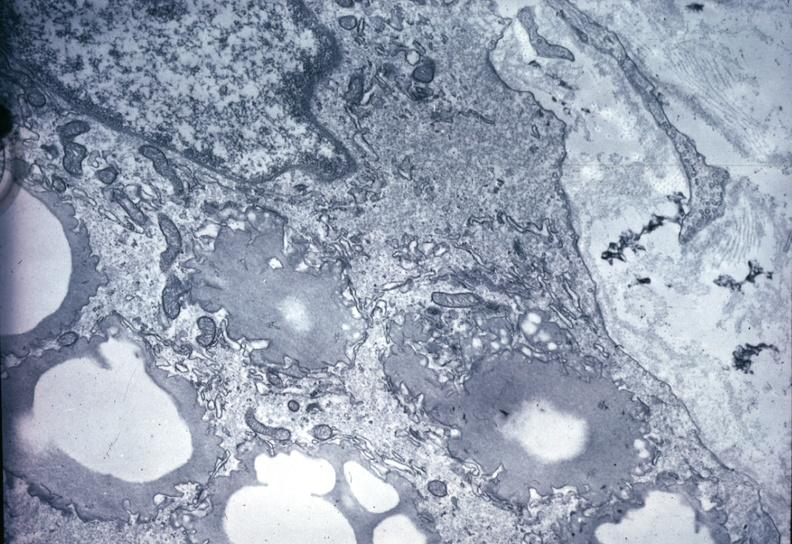s breast present?
Answer the question using a single word or phrase. No 